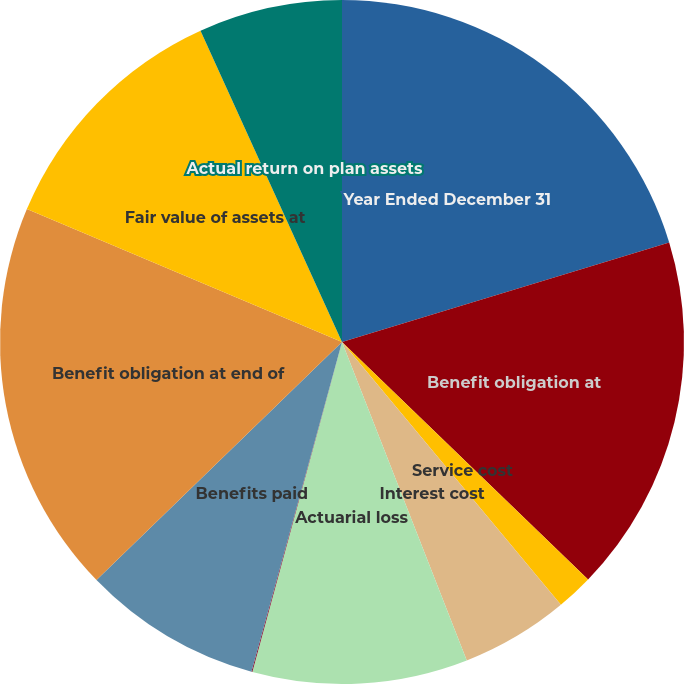<chart> <loc_0><loc_0><loc_500><loc_500><pie_chart><fcel>Year Ended December 31<fcel>Benefit obligation at<fcel>Service cost<fcel>Interest cost<fcel>Actuarial loss<fcel>Settlement/curtailment/other<fcel>Benefits paid<fcel>Benefit obligation at end of<fcel>Fair value of assets at<fcel>Actual return on plan assets<nl><fcel>20.3%<fcel>16.92%<fcel>1.73%<fcel>5.11%<fcel>10.17%<fcel>0.04%<fcel>8.48%<fcel>18.61%<fcel>11.86%<fcel>6.79%<nl></chart> 